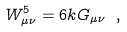<formula> <loc_0><loc_0><loc_500><loc_500>W ^ { 5 } _ { \mu \nu } = 6 k G _ { \mu \nu } \ ,</formula> 